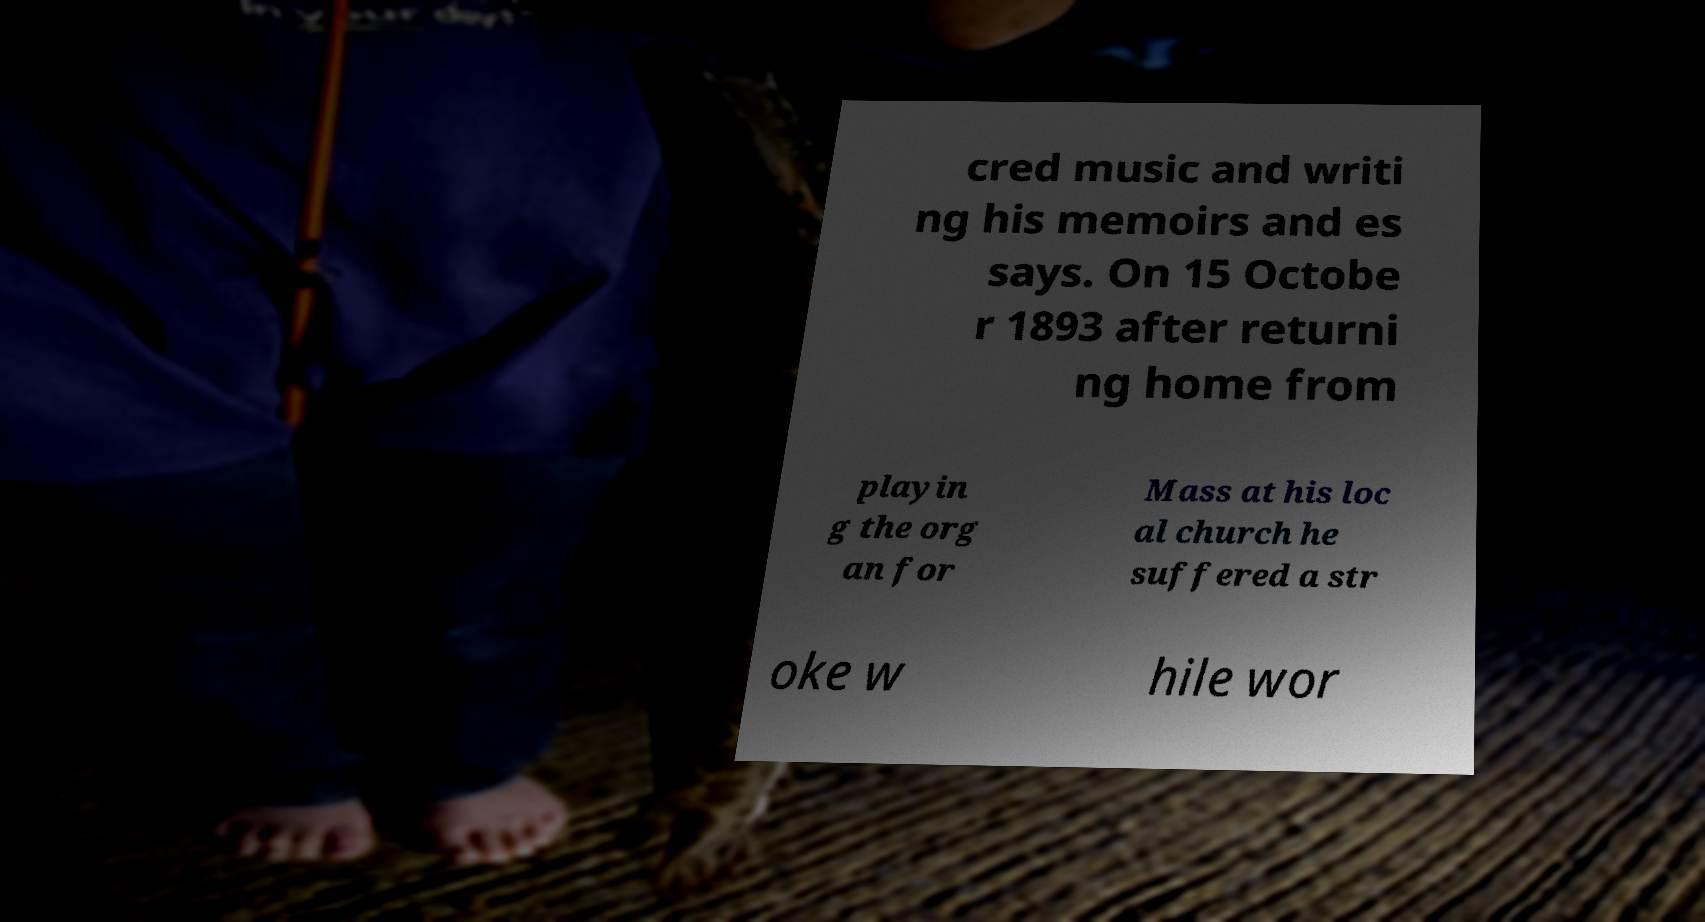Please identify and transcribe the text found in this image. cred music and writi ng his memoirs and es says. On 15 Octobe r 1893 after returni ng home from playin g the org an for Mass at his loc al church he suffered a str oke w hile wor 